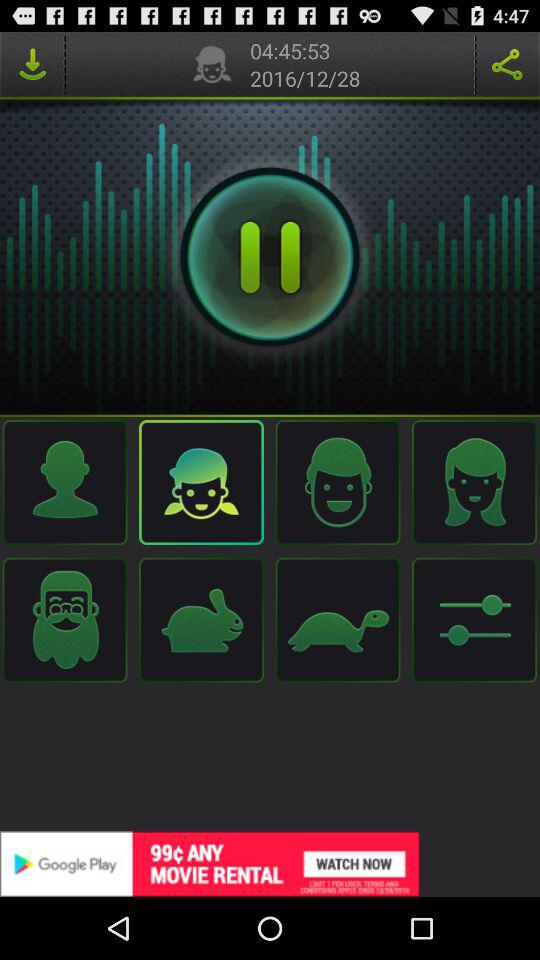What is the mentioned time? The mentioned time is 04:45:53. 